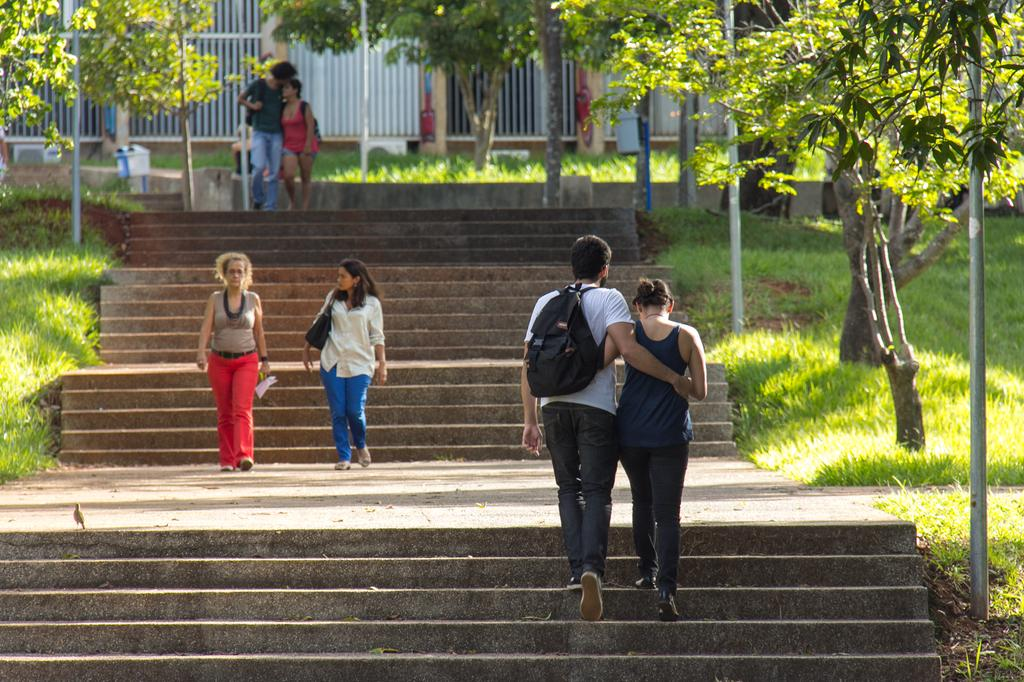What are the people in the image doing? The people in the image are walking. What are the two people carrying? The two people are carrying bags. What architectural feature can be seen in the image? There are steps in the image. What type of vegetation is present in the image? Grass and trees are present in the image. What can be seen in the background of the image? Grills and AC outlets are visible in the background of the image. What word is written on the lunchroom wall in the image? There is no lunchroom present in the image, so no word can be seen on the wall. What type of fan is visible in the image? There is no fan present in the image. 